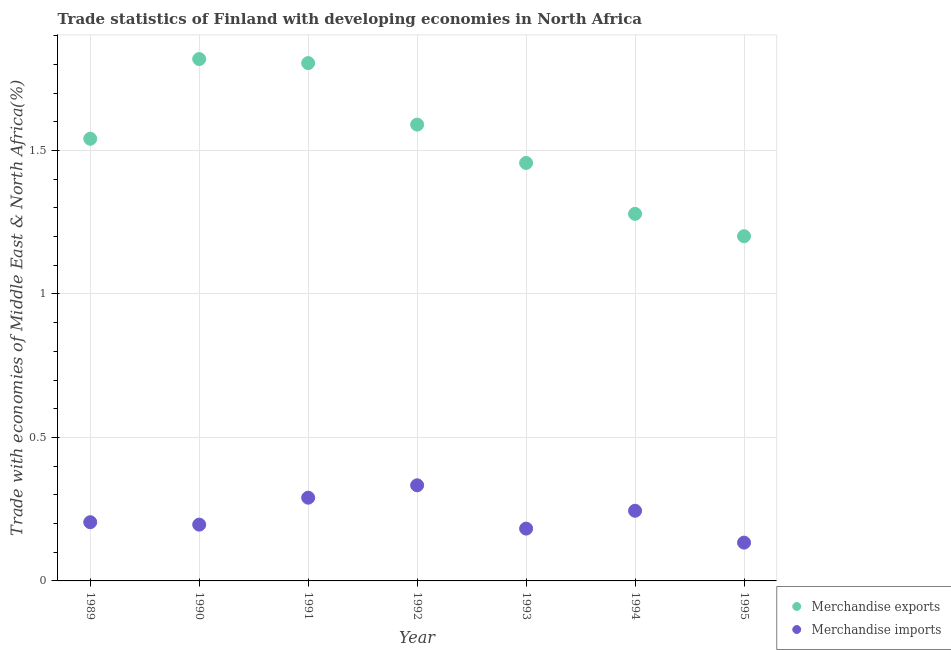How many different coloured dotlines are there?
Give a very brief answer. 2. Is the number of dotlines equal to the number of legend labels?
Ensure brevity in your answer.  Yes. What is the merchandise imports in 1993?
Offer a terse response. 0.18. Across all years, what is the maximum merchandise exports?
Ensure brevity in your answer.  1.82. Across all years, what is the minimum merchandise exports?
Your answer should be compact. 1.2. What is the total merchandise exports in the graph?
Give a very brief answer. 10.69. What is the difference between the merchandise exports in 1990 and that in 1995?
Provide a succinct answer. 0.62. What is the difference between the merchandise exports in 1990 and the merchandise imports in 1995?
Offer a very short reply. 1.68. What is the average merchandise imports per year?
Your response must be concise. 0.23. In the year 1991, what is the difference between the merchandise exports and merchandise imports?
Keep it short and to the point. 1.51. In how many years, is the merchandise exports greater than 1.3 %?
Give a very brief answer. 5. What is the ratio of the merchandise exports in 1994 to that in 1995?
Your answer should be very brief. 1.06. Is the difference between the merchandise imports in 1991 and 1992 greater than the difference between the merchandise exports in 1991 and 1992?
Offer a very short reply. No. What is the difference between the highest and the second highest merchandise imports?
Your answer should be very brief. 0.04. What is the difference between the highest and the lowest merchandise imports?
Your response must be concise. 0.2. Is the sum of the merchandise exports in 1990 and 1991 greater than the maximum merchandise imports across all years?
Offer a terse response. Yes. How many years are there in the graph?
Your answer should be compact. 7. Does the graph contain any zero values?
Provide a succinct answer. No. Where does the legend appear in the graph?
Ensure brevity in your answer.  Bottom right. How many legend labels are there?
Make the answer very short. 2. How are the legend labels stacked?
Offer a very short reply. Vertical. What is the title of the graph?
Offer a very short reply. Trade statistics of Finland with developing economies in North Africa. Does "Exports of goods" appear as one of the legend labels in the graph?
Your answer should be compact. No. What is the label or title of the Y-axis?
Your answer should be very brief. Trade with economies of Middle East & North Africa(%). What is the Trade with economies of Middle East & North Africa(%) in Merchandise exports in 1989?
Your answer should be very brief. 1.54. What is the Trade with economies of Middle East & North Africa(%) of Merchandise imports in 1989?
Provide a short and direct response. 0.2. What is the Trade with economies of Middle East & North Africa(%) in Merchandise exports in 1990?
Provide a short and direct response. 1.82. What is the Trade with economies of Middle East & North Africa(%) of Merchandise imports in 1990?
Keep it short and to the point. 0.2. What is the Trade with economies of Middle East & North Africa(%) in Merchandise exports in 1991?
Your response must be concise. 1.8. What is the Trade with economies of Middle East & North Africa(%) in Merchandise imports in 1991?
Provide a short and direct response. 0.29. What is the Trade with economies of Middle East & North Africa(%) of Merchandise exports in 1992?
Provide a short and direct response. 1.59. What is the Trade with economies of Middle East & North Africa(%) in Merchandise imports in 1992?
Your answer should be very brief. 0.33. What is the Trade with economies of Middle East & North Africa(%) in Merchandise exports in 1993?
Your answer should be compact. 1.46. What is the Trade with economies of Middle East & North Africa(%) in Merchandise imports in 1993?
Give a very brief answer. 0.18. What is the Trade with economies of Middle East & North Africa(%) of Merchandise exports in 1994?
Provide a succinct answer. 1.28. What is the Trade with economies of Middle East & North Africa(%) of Merchandise imports in 1994?
Your response must be concise. 0.24. What is the Trade with economies of Middle East & North Africa(%) in Merchandise exports in 1995?
Your answer should be compact. 1.2. What is the Trade with economies of Middle East & North Africa(%) of Merchandise imports in 1995?
Offer a very short reply. 0.13. Across all years, what is the maximum Trade with economies of Middle East & North Africa(%) in Merchandise exports?
Offer a terse response. 1.82. Across all years, what is the maximum Trade with economies of Middle East & North Africa(%) of Merchandise imports?
Your answer should be very brief. 0.33. Across all years, what is the minimum Trade with economies of Middle East & North Africa(%) in Merchandise exports?
Offer a terse response. 1.2. Across all years, what is the minimum Trade with economies of Middle East & North Africa(%) in Merchandise imports?
Keep it short and to the point. 0.13. What is the total Trade with economies of Middle East & North Africa(%) of Merchandise exports in the graph?
Provide a succinct answer. 10.69. What is the total Trade with economies of Middle East & North Africa(%) of Merchandise imports in the graph?
Keep it short and to the point. 1.58. What is the difference between the Trade with economies of Middle East & North Africa(%) in Merchandise exports in 1989 and that in 1990?
Provide a succinct answer. -0.28. What is the difference between the Trade with economies of Middle East & North Africa(%) of Merchandise imports in 1989 and that in 1990?
Keep it short and to the point. 0.01. What is the difference between the Trade with economies of Middle East & North Africa(%) of Merchandise exports in 1989 and that in 1991?
Provide a succinct answer. -0.26. What is the difference between the Trade with economies of Middle East & North Africa(%) of Merchandise imports in 1989 and that in 1991?
Your answer should be compact. -0.09. What is the difference between the Trade with economies of Middle East & North Africa(%) of Merchandise exports in 1989 and that in 1992?
Provide a short and direct response. -0.05. What is the difference between the Trade with economies of Middle East & North Africa(%) in Merchandise imports in 1989 and that in 1992?
Your response must be concise. -0.13. What is the difference between the Trade with economies of Middle East & North Africa(%) in Merchandise exports in 1989 and that in 1993?
Provide a succinct answer. 0.08. What is the difference between the Trade with economies of Middle East & North Africa(%) in Merchandise imports in 1989 and that in 1993?
Make the answer very short. 0.02. What is the difference between the Trade with economies of Middle East & North Africa(%) of Merchandise exports in 1989 and that in 1994?
Your response must be concise. 0.26. What is the difference between the Trade with economies of Middle East & North Africa(%) of Merchandise imports in 1989 and that in 1994?
Keep it short and to the point. -0.04. What is the difference between the Trade with economies of Middle East & North Africa(%) of Merchandise exports in 1989 and that in 1995?
Give a very brief answer. 0.34. What is the difference between the Trade with economies of Middle East & North Africa(%) of Merchandise imports in 1989 and that in 1995?
Offer a terse response. 0.07. What is the difference between the Trade with economies of Middle East & North Africa(%) in Merchandise exports in 1990 and that in 1991?
Ensure brevity in your answer.  0.01. What is the difference between the Trade with economies of Middle East & North Africa(%) of Merchandise imports in 1990 and that in 1991?
Give a very brief answer. -0.09. What is the difference between the Trade with economies of Middle East & North Africa(%) of Merchandise exports in 1990 and that in 1992?
Offer a very short reply. 0.23. What is the difference between the Trade with economies of Middle East & North Africa(%) of Merchandise imports in 1990 and that in 1992?
Make the answer very short. -0.14. What is the difference between the Trade with economies of Middle East & North Africa(%) in Merchandise exports in 1990 and that in 1993?
Keep it short and to the point. 0.36. What is the difference between the Trade with economies of Middle East & North Africa(%) of Merchandise imports in 1990 and that in 1993?
Provide a short and direct response. 0.01. What is the difference between the Trade with economies of Middle East & North Africa(%) in Merchandise exports in 1990 and that in 1994?
Provide a succinct answer. 0.54. What is the difference between the Trade with economies of Middle East & North Africa(%) of Merchandise imports in 1990 and that in 1994?
Provide a succinct answer. -0.05. What is the difference between the Trade with economies of Middle East & North Africa(%) of Merchandise exports in 1990 and that in 1995?
Give a very brief answer. 0.62. What is the difference between the Trade with economies of Middle East & North Africa(%) of Merchandise imports in 1990 and that in 1995?
Keep it short and to the point. 0.06. What is the difference between the Trade with economies of Middle East & North Africa(%) in Merchandise exports in 1991 and that in 1992?
Make the answer very short. 0.21. What is the difference between the Trade with economies of Middle East & North Africa(%) of Merchandise imports in 1991 and that in 1992?
Provide a short and direct response. -0.04. What is the difference between the Trade with economies of Middle East & North Africa(%) in Merchandise exports in 1991 and that in 1993?
Make the answer very short. 0.35. What is the difference between the Trade with economies of Middle East & North Africa(%) in Merchandise imports in 1991 and that in 1993?
Offer a terse response. 0.11. What is the difference between the Trade with economies of Middle East & North Africa(%) of Merchandise exports in 1991 and that in 1994?
Offer a terse response. 0.53. What is the difference between the Trade with economies of Middle East & North Africa(%) in Merchandise imports in 1991 and that in 1994?
Ensure brevity in your answer.  0.05. What is the difference between the Trade with economies of Middle East & North Africa(%) in Merchandise exports in 1991 and that in 1995?
Make the answer very short. 0.6. What is the difference between the Trade with economies of Middle East & North Africa(%) in Merchandise imports in 1991 and that in 1995?
Keep it short and to the point. 0.16. What is the difference between the Trade with economies of Middle East & North Africa(%) of Merchandise exports in 1992 and that in 1993?
Your answer should be compact. 0.13. What is the difference between the Trade with economies of Middle East & North Africa(%) of Merchandise imports in 1992 and that in 1993?
Keep it short and to the point. 0.15. What is the difference between the Trade with economies of Middle East & North Africa(%) of Merchandise exports in 1992 and that in 1994?
Give a very brief answer. 0.31. What is the difference between the Trade with economies of Middle East & North Africa(%) of Merchandise imports in 1992 and that in 1994?
Your response must be concise. 0.09. What is the difference between the Trade with economies of Middle East & North Africa(%) of Merchandise exports in 1992 and that in 1995?
Provide a short and direct response. 0.39. What is the difference between the Trade with economies of Middle East & North Africa(%) of Merchandise imports in 1992 and that in 1995?
Your answer should be compact. 0.2. What is the difference between the Trade with economies of Middle East & North Africa(%) of Merchandise exports in 1993 and that in 1994?
Your answer should be compact. 0.18. What is the difference between the Trade with economies of Middle East & North Africa(%) of Merchandise imports in 1993 and that in 1994?
Your answer should be very brief. -0.06. What is the difference between the Trade with economies of Middle East & North Africa(%) in Merchandise exports in 1993 and that in 1995?
Your answer should be very brief. 0.26. What is the difference between the Trade with economies of Middle East & North Africa(%) of Merchandise imports in 1993 and that in 1995?
Make the answer very short. 0.05. What is the difference between the Trade with economies of Middle East & North Africa(%) of Merchandise exports in 1994 and that in 1995?
Offer a very short reply. 0.08. What is the difference between the Trade with economies of Middle East & North Africa(%) in Merchandise imports in 1994 and that in 1995?
Provide a short and direct response. 0.11. What is the difference between the Trade with economies of Middle East & North Africa(%) in Merchandise exports in 1989 and the Trade with economies of Middle East & North Africa(%) in Merchandise imports in 1990?
Provide a short and direct response. 1.34. What is the difference between the Trade with economies of Middle East & North Africa(%) of Merchandise exports in 1989 and the Trade with economies of Middle East & North Africa(%) of Merchandise imports in 1991?
Keep it short and to the point. 1.25. What is the difference between the Trade with economies of Middle East & North Africa(%) in Merchandise exports in 1989 and the Trade with economies of Middle East & North Africa(%) in Merchandise imports in 1992?
Offer a very short reply. 1.21. What is the difference between the Trade with economies of Middle East & North Africa(%) of Merchandise exports in 1989 and the Trade with economies of Middle East & North Africa(%) of Merchandise imports in 1993?
Provide a short and direct response. 1.36. What is the difference between the Trade with economies of Middle East & North Africa(%) in Merchandise exports in 1989 and the Trade with economies of Middle East & North Africa(%) in Merchandise imports in 1994?
Keep it short and to the point. 1.3. What is the difference between the Trade with economies of Middle East & North Africa(%) in Merchandise exports in 1989 and the Trade with economies of Middle East & North Africa(%) in Merchandise imports in 1995?
Provide a short and direct response. 1.41. What is the difference between the Trade with economies of Middle East & North Africa(%) of Merchandise exports in 1990 and the Trade with economies of Middle East & North Africa(%) of Merchandise imports in 1991?
Offer a terse response. 1.53. What is the difference between the Trade with economies of Middle East & North Africa(%) of Merchandise exports in 1990 and the Trade with economies of Middle East & North Africa(%) of Merchandise imports in 1992?
Ensure brevity in your answer.  1.49. What is the difference between the Trade with economies of Middle East & North Africa(%) of Merchandise exports in 1990 and the Trade with economies of Middle East & North Africa(%) of Merchandise imports in 1993?
Provide a short and direct response. 1.64. What is the difference between the Trade with economies of Middle East & North Africa(%) in Merchandise exports in 1990 and the Trade with economies of Middle East & North Africa(%) in Merchandise imports in 1994?
Offer a very short reply. 1.57. What is the difference between the Trade with economies of Middle East & North Africa(%) of Merchandise exports in 1990 and the Trade with economies of Middle East & North Africa(%) of Merchandise imports in 1995?
Provide a short and direct response. 1.69. What is the difference between the Trade with economies of Middle East & North Africa(%) in Merchandise exports in 1991 and the Trade with economies of Middle East & North Africa(%) in Merchandise imports in 1992?
Provide a short and direct response. 1.47. What is the difference between the Trade with economies of Middle East & North Africa(%) of Merchandise exports in 1991 and the Trade with economies of Middle East & North Africa(%) of Merchandise imports in 1993?
Ensure brevity in your answer.  1.62. What is the difference between the Trade with economies of Middle East & North Africa(%) in Merchandise exports in 1991 and the Trade with economies of Middle East & North Africa(%) in Merchandise imports in 1994?
Make the answer very short. 1.56. What is the difference between the Trade with economies of Middle East & North Africa(%) in Merchandise exports in 1991 and the Trade with economies of Middle East & North Africa(%) in Merchandise imports in 1995?
Your response must be concise. 1.67. What is the difference between the Trade with economies of Middle East & North Africa(%) in Merchandise exports in 1992 and the Trade with economies of Middle East & North Africa(%) in Merchandise imports in 1993?
Keep it short and to the point. 1.41. What is the difference between the Trade with economies of Middle East & North Africa(%) of Merchandise exports in 1992 and the Trade with economies of Middle East & North Africa(%) of Merchandise imports in 1994?
Offer a very short reply. 1.35. What is the difference between the Trade with economies of Middle East & North Africa(%) of Merchandise exports in 1992 and the Trade with economies of Middle East & North Africa(%) of Merchandise imports in 1995?
Ensure brevity in your answer.  1.46. What is the difference between the Trade with economies of Middle East & North Africa(%) in Merchandise exports in 1993 and the Trade with economies of Middle East & North Africa(%) in Merchandise imports in 1994?
Provide a succinct answer. 1.21. What is the difference between the Trade with economies of Middle East & North Africa(%) of Merchandise exports in 1993 and the Trade with economies of Middle East & North Africa(%) of Merchandise imports in 1995?
Keep it short and to the point. 1.32. What is the difference between the Trade with economies of Middle East & North Africa(%) in Merchandise exports in 1994 and the Trade with economies of Middle East & North Africa(%) in Merchandise imports in 1995?
Give a very brief answer. 1.15. What is the average Trade with economies of Middle East & North Africa(%) of Merchandise exports per year?
Your answer should be very brief. 1.53. What is the average Trade with economies of Middle East & North Africa(%) in Merchandise imports per year?
Make the answer very short. 0.23. In the year 1989, what is the difference between the Trade with economies of Middle East & North Africa(%) of Merchandise exports and Trade with economies of Middle East & North Africa(%) of Merchandise imports?
Your answer should be very brief. 1.34. In the year 1990, what is the difference between the Trade with economies of Middle East & North Africa(%) of Merchandise exports and Trade with economies of Middle East & North Africa(%) of Merchandise imports?
Offer a very short reply. 1.62. In the year 1991, what is the difference between the Trade with economies of Middle East & North Africa(%) of Merchandise exports and Trade with economies of Middle East & North Africa(%) of Merchandise imports?
Make the answer very short. 1.51. In the year 1992, what is the difference between the Trade with economies of Middle East & North Africa(%) in Merchandise exports and Trade with economies of Middle East & North Africa(%) in Merchandise imports?
Offer a terse response. 1.26. In the year 1993, what is the difference between the Trade with economies of Middle East & North Africa(%) in Merchandise exports and Trade with economies of Middle East & North Africa(%) in Merchandise imports?
Offer a terse response. 1.27. In the year 1994, what is the difference between the Trade with economies of Middle East & North Africa(%) of Merchandise exports and Trade with economies of Middle East & North Africa(%) of Merchandise imports?
Offer a terse response. 1.03. In the year 1995, what is the difference between the Trade with economies of Middle East & North Africa(%) of Merchandise exports and Trade with economies of Middle East & North Africa(%) of Merchandise imports?
Provide a succinct answer. 1.07. What is the ratio of the Trade with economies of Middle East & North Africa(%) in Merchandise exports in 1989 to that in 1990?
Provide a short and direct response. 0.85. What is the ratio of the Trade with economies of Middle East & North Africa(%) in Merchandise imports in 1989 to that in 1990?
Provide a succinct answer. 1.04. What is the ratio of the Trade with economies of Middle East & North Africa(%) in Merchandise exports in 1989 to that in 1991?
Provide a succinct answer. 0.85. What is the ratio of the Trade with economies of Middle East & North Africa(%) in Merchandise imports in 1989 to that in 1991?
Offer a terse response. 0.71. What is the ratio of the Trade with economies of Middle East & North Africa(%) in Merchandise exports in 1989 to that in 1992?
Ensure brevity in your answer.  0.97. What is the ratio of the Trade with economies of Middle East & North Africa(%) of Merchandise imports in 1989 to that in 1992?
Give a very brief answer. 0.61. What is the ratio of the Trade with economies of Middle East & North Africa(%) of Merchandise exports in 1989 to that in 1993?
Ensure brevity in your answer.  1.06. What is the ratio of the Trade with economies of Middle East & North Africa(%) of Merchandise imports in 1989 to that in 1993?
Offer a terse response. 1.12. What is the ratio of the Trade with economies of Middle East & North Africa(%) in Merchandise exports in 1989 to that in 1994?
Give a very brief answer. 1.2. What is the ratio of the Trade with economies of Middle East & North Africa(%) in Merchandise imports in 1989 to that in 1994?
Your answer should be compact. 0.84. What is the ratio of the Trade with economies of Middle East & North Africa(%) in Merchandise exports in 1989 to that in 1995?
Provide a succinct answer. 1.28. What is the ratio of the Trade with economies of Middle East & North Africa(%) in Merchandise imports in 1989 to that in 1995?
Offer a very short reply. 1.53. What is the ratio of the Trade with economies of Middle East & North Africa(%) in Merchandise imports in 1990 to that in 1991?
Offer a terse response. 0.68. What is the ratio of the Trade with economies of Middle East & North Africa(%) of Merchandise exports in 1990 to that in 1992?
Provide a short and direct response. 1.14. What is the ratio of the Trade with economies of Middle East & North Africa(%) in Merchandise imports in 1990 to that in 1992?
Provide a short and direct response. 0.59. What is the ratio of the Trade with economies of Middle East & North Africa(%) of Merchandise exports in 1990 to that in 1993?
Provide a short and direct response. 1.25. What is the ratio of the Trade with economies of Middle East & North Africa(%) in Merchandise imports in 1990 to that in 1993?
Ensure brevity in your answer.  1.08. What is the ratio of the Trade with economies of Middle East & North Africa(%) of Merchandise exports in 1990 to that in 1994?
Ensure brevity in your answer.  1.42. What is the ratio of the Trade with economies of Middle East & North Africa(%) of Merchandise imports in 1990 to that in 1994?
Offer a terse response. 0.8. What is the ratio of the Trade with economies of Middle East & North Africa(%) of Merchandise exports in 1990 to that in 1995?
Ensure brevity in your answer.  1.51. What is the ratio of the Trade with economies of Middle East & North Africa(%) in Merchandise imports in 1990 to that in 1995?
Ensure brevity in your answer.  1.47. What is the ratio of the Trade with economies of Middle East & North Africa(%) of Merchandise exports in 1991 to that in 1992?
Ensure brevity in your answer.  1.13. What is the ratio of the Trade with economies of Middle East & North Africa(%) in Merchandise imports in 1991 to that in 1992?
Your answer should be compact. 0.87. What is the ratio of the Trade with economies of Middle East & North Africa(%) of Merchandise exports in 1991 to that in 1993?
Give a very brief answer. 1.24. What is the ratio of the Trade with economies of Middle East & North Africa(%) in Merchandise imports in 1991 to that in 1993?
Offer a terse response. 1.59. What is the ratio of the Trade with economies of Middle East & North Africa(%) of Merchandise exports in 1991 to that in 1994?
Your answer should be compact. 1.41. What is the ratio of the Trade with economies of Middle East & North Africa(%) in Merchandise imports in 1991 to that in 1994?
Your answer should be compact. 1.19. What is the ratio of the Trade with economies of Middle East & North Africa(%) of Merchandise exports in 1991 to that in 1995?
Provide a short and direct response. 1.5. What is the ratio of the Trade with economies of Middle East & North Africa(%) in Merchandise imports in 1991 to that in 1995?
Keep it short and to the point. 2.17. What is the ratio of the Trade with economies of Middle East & North Africa(%) in Merchandise exports in 1992 to that in 1993?
Your answer should be very brief. 1.09. What is the ratio of the Trade with economies of Middle East & North Africa(%) in Merchandise imports in 1992 to that in 1993?
Give a very brief answer. 1.83. What is the ratio of the Trade with economies of Middle East & North Africa(%) in Merchandise exports in 1992 to that in 1994?
Offer a terse response. 1.24. What is the ratio of the Trade with economies of Middle East & North Africa(%) of Merchandise imports in 1992 to that in 1994?
Give a very brief answer. 1.36. What is the ratio of the Trade with economies of Middle East & North Africa(%) of Merchandise exports in 1992 to that in 1995?
Your response must be concise. 1.32. What is the ratio of the Trade with economies of Middle East & North Africa(%) in Merchandise imports in 1992 to that in 1995?
Ensure brevity in your answer.  2.5. What is the ratio of the Trade with economies of Middle East & North Africa(%) of Merchandise exports in 1993 to that in 1994?
Offer a terse response. 1.14. What is the ratio of the Trade with economies of Middle East & North Africa(%) of Merchandise imports in 1993 to that in 1994?
Ensure brevity in your answer.  0.75. What is the ratio of the Trade with economies of Middle East & North Africa(%) in Merchandise exports in 1993 to that in 1995?
Offer a very short reply. 1.21. What is the ratio of the Trade with economies of Middle East & North Africa(%) of Merchandise imports in 1993 to that in 1995?
Offer a very short reply. 1.37. What is the ratio of the Trade with economies of Middle East & North Africa(%) of Merchandise exports in 1994 to that in 1995?
Your response must be concise. 1.06. What is the ratio of the Trade with economies of Middle East & North Africa(%) in Merchandise imports in 1994 to that in 1995?
Ensure brevity in your answer.  1.83. What is the difference between the highest and the second highest Trade with economies of Middle East & North Africa(%) in Merchandise exports?
Ensure brevity in your answer.  0.01. What is the difference between the highest and the second highest Trade with economies of Middle East & North Africa(%) of Merchandise imports?
Your response must be concise. 0.04. What is the difference between the highest and the lowest Trade with economies of Middle East & North Africa(%) of Merchandise exports?
Your answer should be compact. 0.62. What is the difference between the highest and the lowest Trade with economies of Middle East & North Africa(%) in Merchandise imports?
Keep it short and to the point. 0.2. 